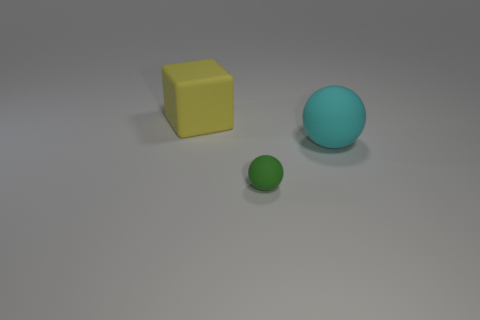Is the number of small rubber balls that are behind the green object greater than the number of large matte objects?
Your response must be concise. No. There is a big object that is to the left of the cyan matte ball; is its shape the same as the large cyan thing?
Give a very brief answer. No. What number of red things are either rubber cubes or rubber balls?
Your answer should be compact. 0. Are there more cyan spheres than tiny cyan things?
Your answer should be compact. Yes. The other matte thing that is the same size as the cyan thing is what color?
Offer a terse response. Yellow. What number of blocks are cyan matte things or big red matte objects?
Keep it short and to the point. 0. Is the shape of the yellow matte thing the same as the matte thing in front of the large cyan matte thing?
Your answer should be very brief. No. What number of matte blocks have the same size as the yellow thing?
Make the answer very short. 0. Do the big object that is behind the cyan thing and the big matte object that is right of the tiny green ball have the same shape?
Your response must be concise. No. The big thing that is behind the rubber sphere that is to the right of the green thing is what color?
Keep it short and to the point. Yellow. 